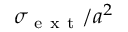Convert formula to latex. <formula><loc_0><loc_0><loc_500><loc_500>\sigma _ { e x t } / a ^ { 2 }</formula> 